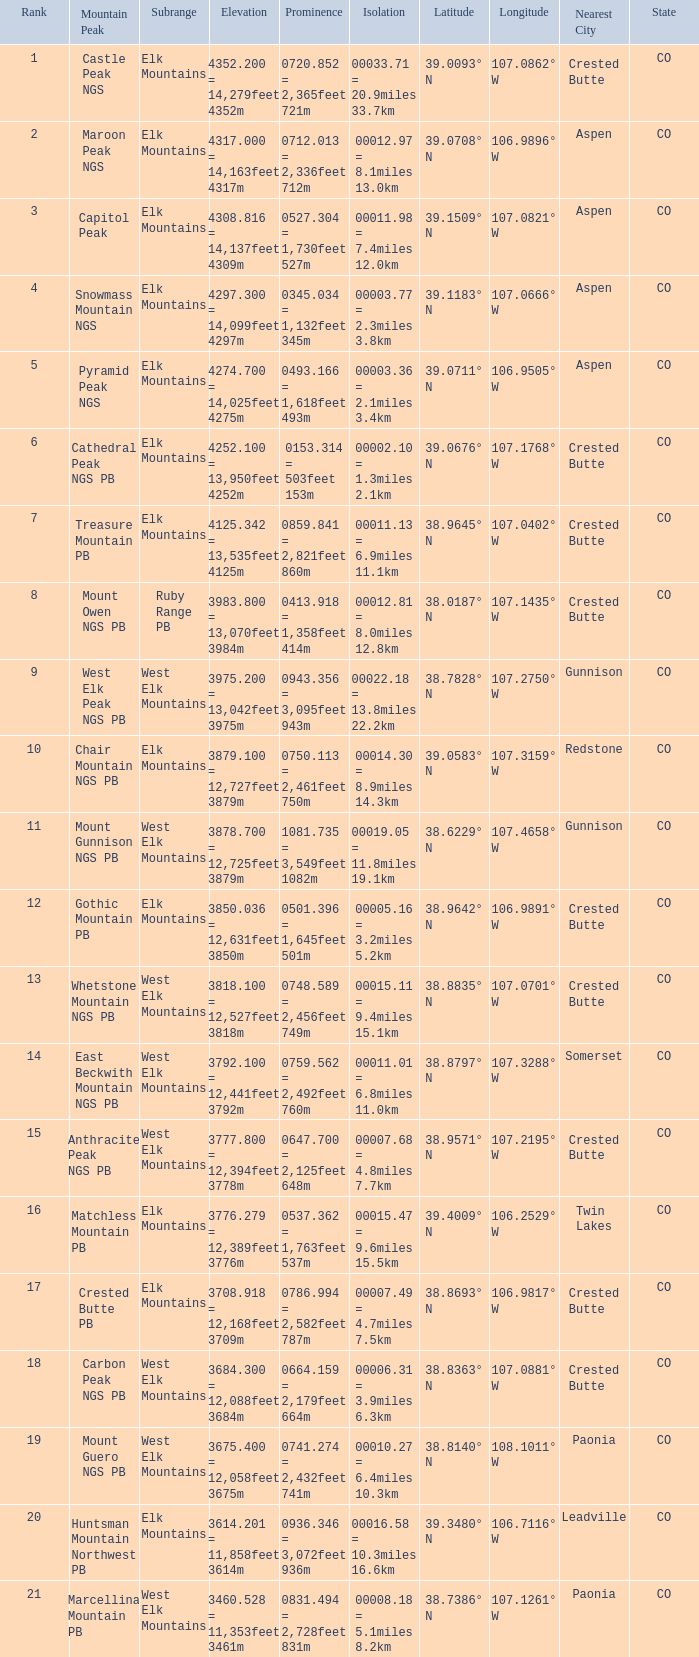Name the Prominence of the Mountain Peak of matchless mountain pb? 0537.362 = 1,763feet 537m. 